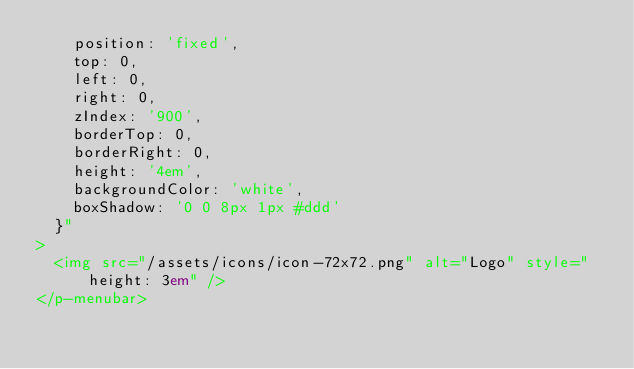<code> <loc_0><loc_0><loc_500><loc_500><_HTML_>    position: 'fixed',
    top: 0,
    left: 0,
    right: 0,
    zIndex: '900',
    borderTop: 0,
    borderRight: 0,
    height: '4em',
    backgroundColor: 'white',
    boxShadow: '0 0 8px 1px #ddd'
  }"
>
  <img src="/assets/icons/icon-72x72.png" alt="Logo" style="height: 3em" />
</p-menubar>
</code> 